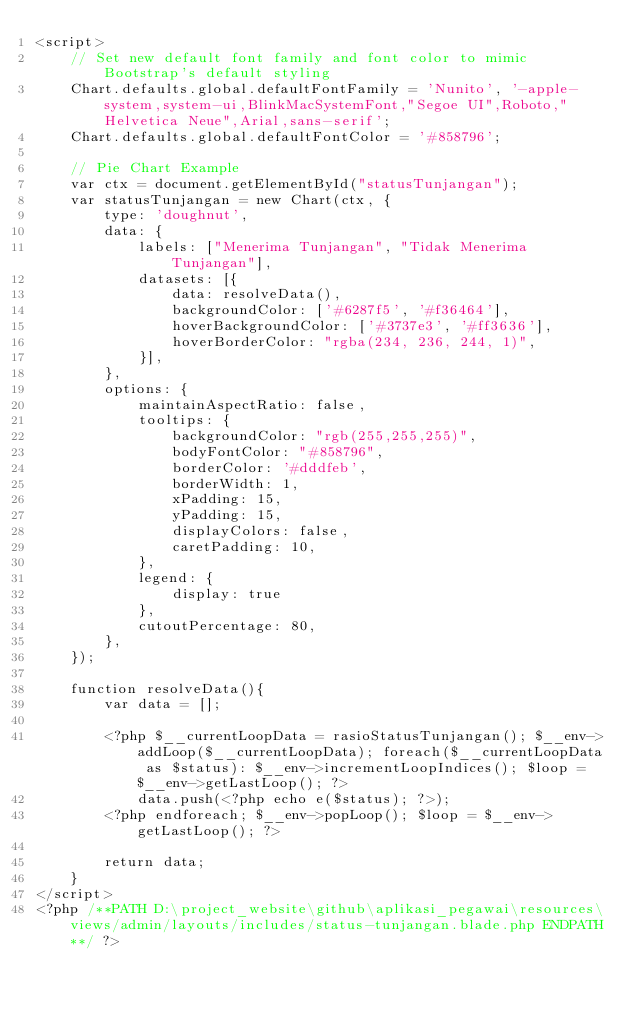Convert code to text. <code><loc_0><loc_0><loc_500><loc_500><_PHP_><script>
    // Set new default font family and font color to mimic Bootstrap's default styling
    Chart.defaults.global.defaultFontFamily = 'Nunito', '-apple-system,system-ui,BlinkMacSystemFont,"Segoe UI",Roboto,"Helvetica Neue",Arial,sans-serif';
    Chart.defaults.global.defaultFontColor = '#858796';

    // Pie Chart Example
    var ctx = document.getElementById("statusTunjangan");
    var statusTunjangan = new Chart(ctx, {
        type: 'doughnut',
        data: {
            labels: ["Menerima Tunjangan", "Tidak Menerima Tunjangan"],
            datasets: [{
                data: resolveData(),
                backgroundColor: ['#6287f5', '#f36464'],
                hoverBackgroundColor: ['#3737e3', '#ff3636'],
                hoverBorderColor: "rgba(234, 236, 244, 1)",
            }],
        },
        options: {
            maintainAspectRatio: false,
            tooltips: {
                backgroundColor: "rgb(255,255,255)",
                bodyFontColor: "#858796",
                borderColor: '#dddfeb',
                borderWidth: 1,
                xPadding: 15,
                yPadding: 15,
                displayColors: false,
                caretPadding: 10,
            },
            legend: {
                display: true
            },
            cutoutPercentage: 80,
        },
    });

    function resolveData(){
        var data = [];

        <?php $__currentLoopData = rasioStatusTunjangan(); $__env->addLoop($__currentLoopData); foreach($__currentLoopData as $status): $__env->incrementLoopIndices(); $loop = $__env->getLastLoop(); ?>
            data.push(<?php echo e($status); ?>);
        <?php endforeach; $__env->popLoop(); $loop = $__env->getLastLoop(); ?>

        return data;
    }
</script>
<?php /**PATH D:\project_website\github\aplikasi_pegawai\resources\views/admin/layouts/includes/status-tunjangan.blade.php ENDPATH**/ ?></code> 